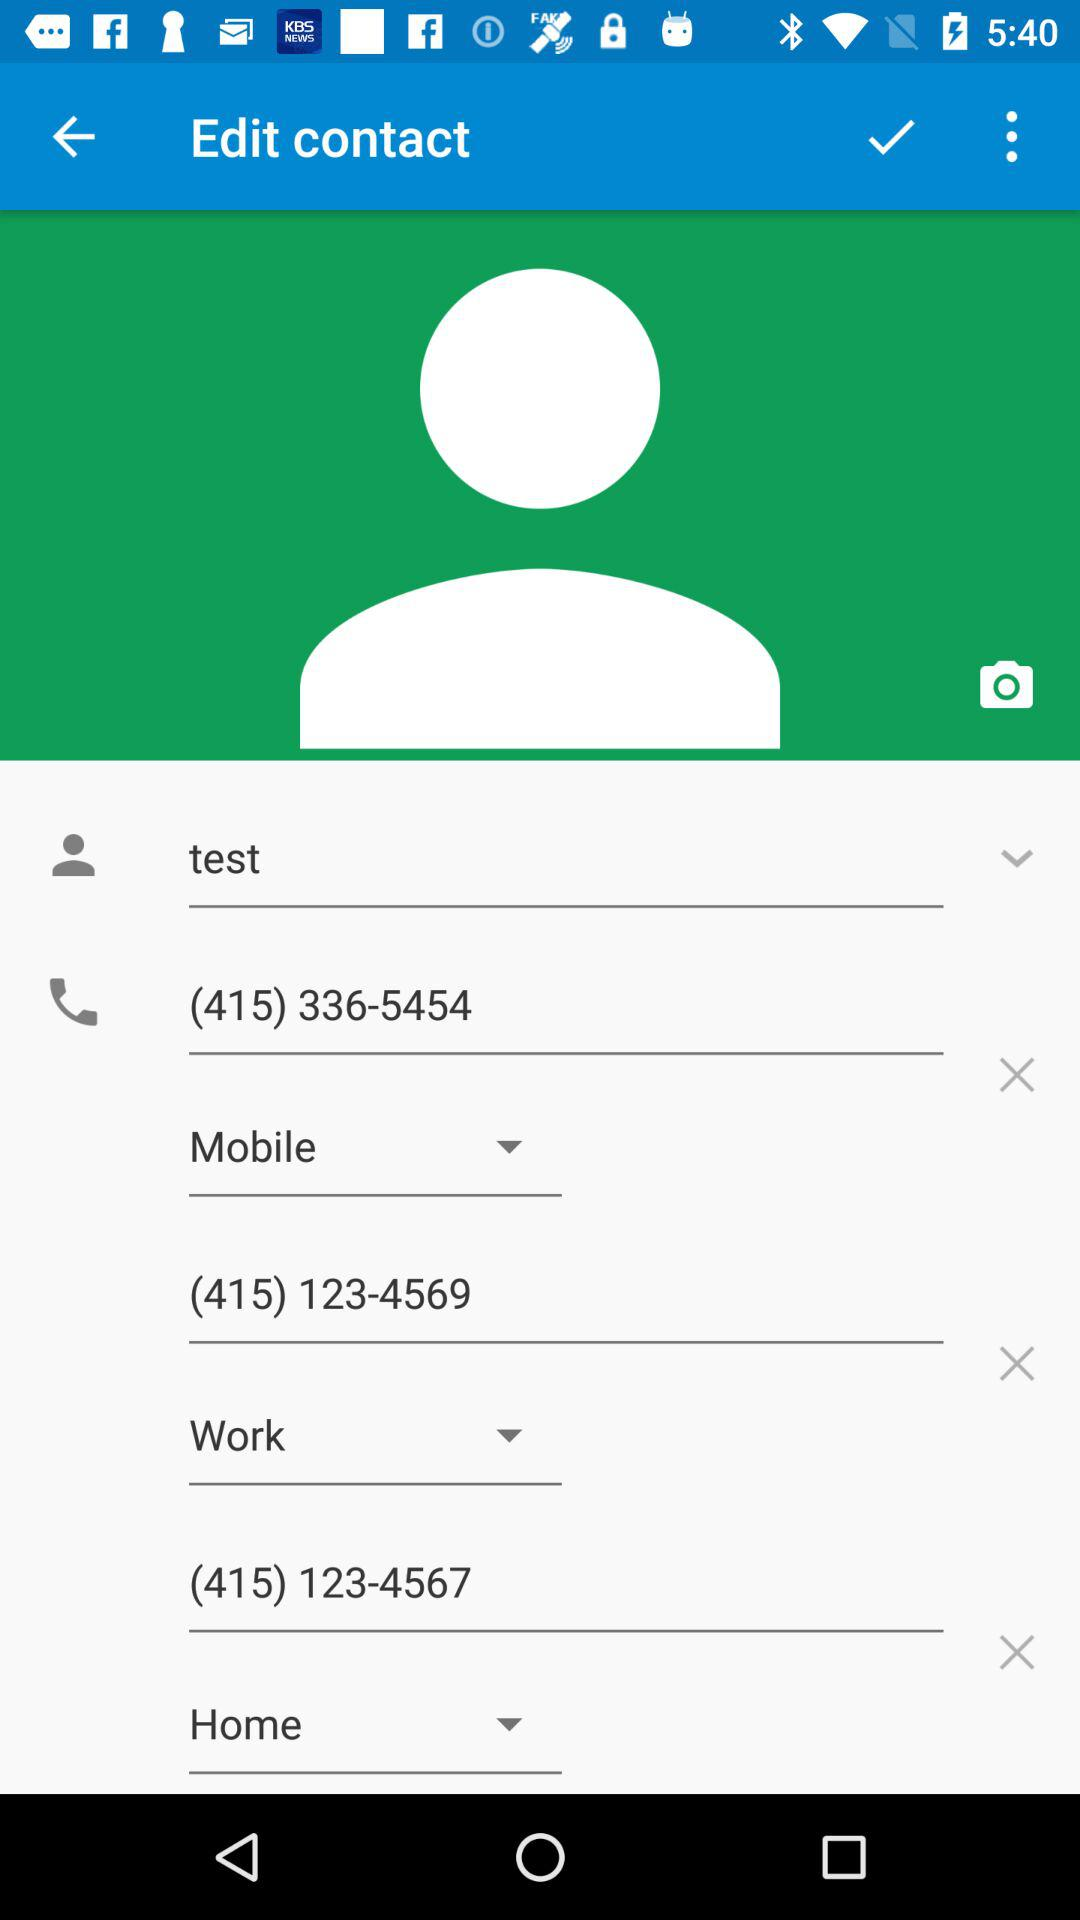What are the mobile numbers? The mobile numbers are (415) 336-5454, (415) 123-4569, and (415) 123-4567. 